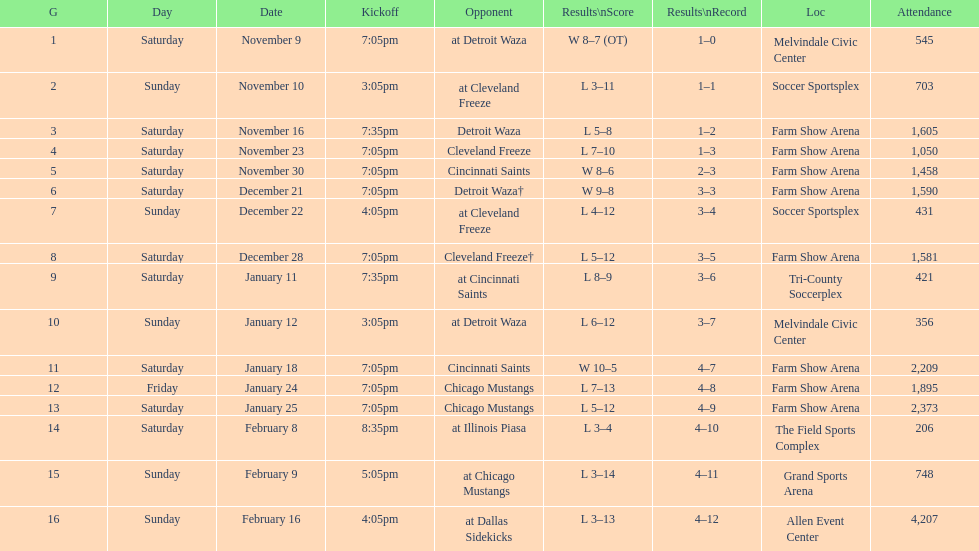How many games did the harrisburg heat lose to the cleveland freeze in total. 4. 